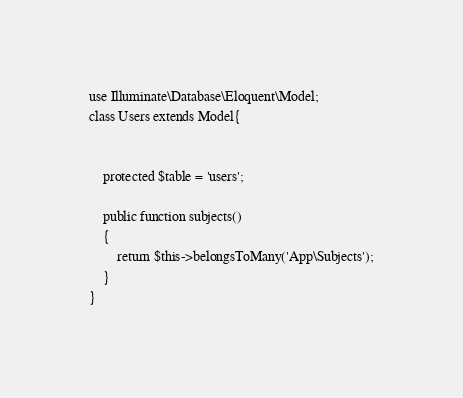Convert code to text. <code><loc_0><loc_0><loc_500><loc_500><_PHP_>use Illuminate\Database\Eloquent\Model;
class Users extends Model{


	protected $table = 'users';

	public function subjects()
    {
        return $this->belongsToMany('App\Subjects');
    }
}</code> 